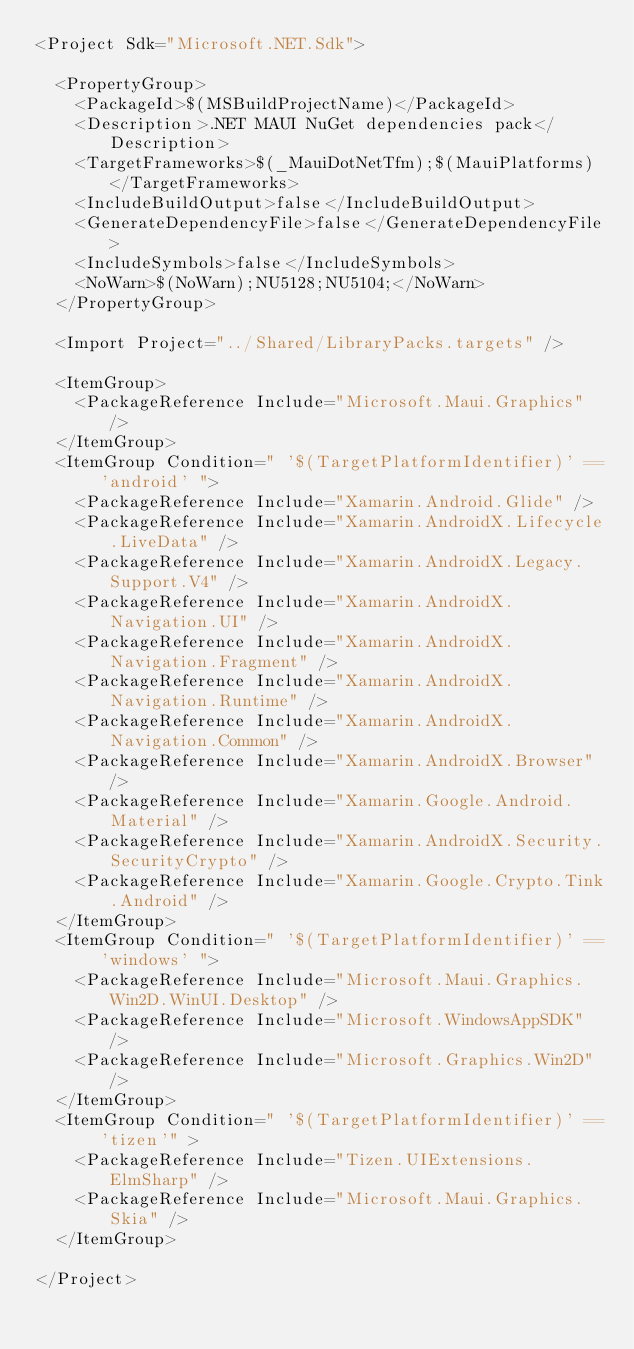<code> <loc_0><loc_0><loc_500><loc_500><_XML_><Project Sdk="Microsoft.NET.Sdk">

  <PropertyGroup>
    <PackageId>$(MSBuildProjectName)</PackageId>
    <Description>.NET MAUI NuGet dependencies pack</Description>
    <TargetFrameworks>$(_MauiDotNetTfm);$(MauiPlatforms)</TargetFrameworks>
    <IncludeBuildOutput>false</IncludeBuildOutput>
    <GenerateDependencyFile>false</GenerateDependencyFile>
    <IncludeSymbols>false</IncludeSymbols>
    <NoWarn>$(NoWarn);NU5128;NU5104;</NoWarn>
  </PropertyGroup>

  <Import Project="../Shared/LibraryPacks.targets" />

  <ItemGroup>
    <PackageReference Include="Microsoft.Maui.Graphics" />
  </ItemGroup>
  <ItemGroup Condition=" '$(TargetPlatformIdentifier)' == 'android' ">
    <PackageReference Include="Xamarin.Android.Glide" />
    <PackageReference Include="Xamarin.AndroidX.Lifecycle.LiveData" />
    <PackageReference Include="Xamarin.AndroidX.Legacy.Support.V4" />
    <PackageReference Include="Xamarin.AndroidX.Navigation.UI" />
    <PackageReference Include="Xamarin.AndroidX.Navigation.Fragment" />
    <PackageReference Include="Xamarin.AndroidX.Navigation.Runtime" />
    <PackageReference Include="Xamarin.AndroidX.Navigation.Common" />
    <PackageReference Include="Xamarin.AndroidX.Browser" />
    <PackageReference Include="Xamarin.Google.Android.Material" />
    <PackageReference Include="Xamarin.AndroidX.Security.SecurityCrypto" />
    <PackageReference Include="Xamarin.Google.Crypto.Tink.Android" />
  </ItemGroup>
  <ItemGroup Condition=" '$(TargetPlatformIdentifier)' == 'windows' ">
    <PackageReference Include="Microsoft.Maui.Graphics.Win2D.WinUI.Desktop" />
    <PackageReference Include="Microsoft.WindowsAppSDK" />
    <PackageReference Include="Microsoft.Graphics.Win2D" />
  </ItemGroup>
  <ItemGroup Condition=" '$(TargetPlatformIdentifier)' == 'tizen'" >
    <PackageReference Include="Tizen.UIExtensions.ElmSharp" />
    <PackageReference Include="Microsoft.Maui.Graphics.Skia" />
  </ItemGroup>

</Project>
</code> 